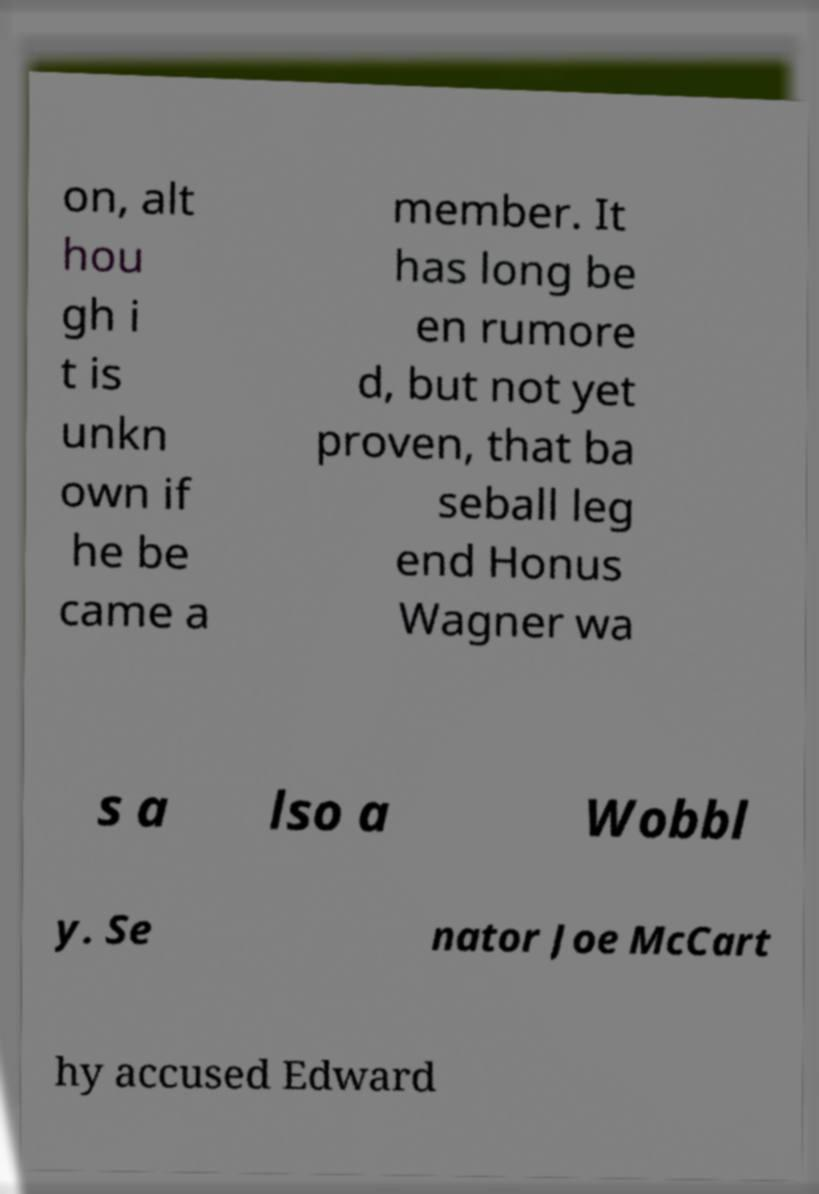Can you read and provide the text displayed in the image?This photo seems to have some interesting text. Can you extract and type it out for me? on, alt hou gh i t is unkn own if he be came a member. It has long be en rumore d, but not yet proven, that ba seball leg end Honus Wagner wa s a lso a Wobbl y. Se nator Joe McCart hy accused Edward 